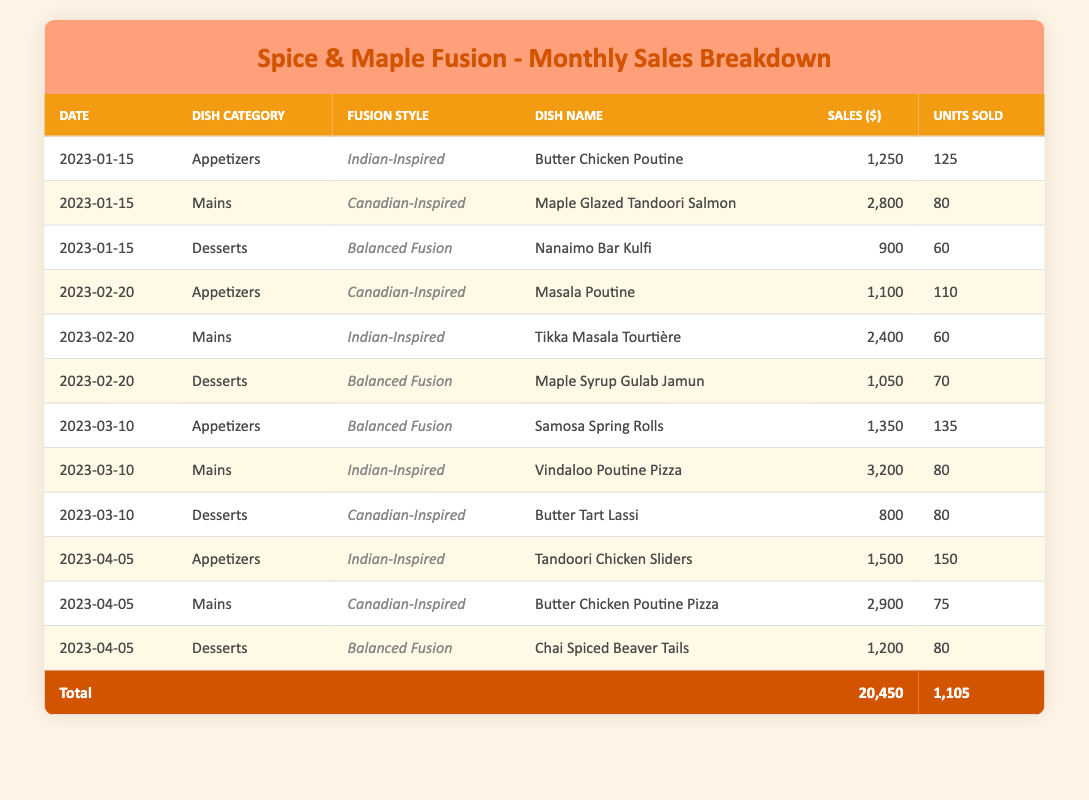What was the total sales amount for January 2023? To find the total sales for January 2023, I look for all rows with the date "2023-01-15". The sales amounts for that date are 1250, 2800, and 900. Adding these values gives 1250 + 2800 + 900 = 4950.
Answer: 4950 Which dish had the highest sales in February 2023? In February 2023, the sales for each dish were: Masala Poutine (1100), Tikka Masala Tourtière (2400), and Maple Syrup Gulab Jamun (1050). The highest sales amount among these is 2400 for Tikka Masala Tourtière.
Answer: Tikka Masala Tourtière Did the total sales for appetizers exceed those for desserts in March 2023? In March 2023, the sales for appetizers were: Samosa Spring Rolls (1350), and the total for desserts were Butter Tart Lassi (800). 1350 > 800, so total appetizers sales exceed dessert sales.
Answer: Yes What percentage of total sales were from the 'Indian-Inspired' fusion style? The total sales for 'Indian-Inspired' fusion style dishes are 1250 (Jan) + 2400 (Feb) + 3200 (Mar) + 1500 (Apr) = 8350. The overall total sales are 20450. To find the percentage, divide 8350 by 20450 and multiply by 100: (8350 / 20450) * 100 = 40.8%.
Answer: 40.8% How many units of the 'Balanced Fusion' dishes were sold in total? The 'Balanced Fusion' dishes sold are: Nanaimo Bar Kulfi (60), Maple Syrup Gulab Jamun (70), Butter Tart Lassi (80), and Chai Spiced Beaver Tails (80), with totals of 60 + 70 + 80 + 80 = 290 units sold overall.
Answer: 290 